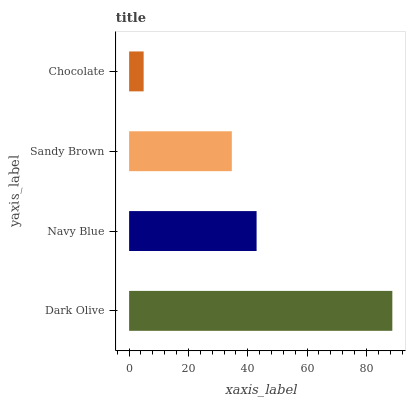Is Chocolate the minimum?
Answer yes or no. Yes. Is Dark Olive the maximum?
Answer yes or no. Yes. Is Navy Blue the minimum?
Answer yes or no. No. Is Navy Blue the maximum?
Answer yes or no. No. Is Dark Olive greater than Navy Blue?
Answer yes or no. Yes. Is Navy Blue less than Dark Olive?
Answer yes or no. Yes. Is Navy Blue greater than Dark Olive?
Answer yes or no. No. Is Dark Olive less than Navy Blue?
Answer yes or no. No. Is Navy Blue the high median?
Answer yes or no. Yes. Is Sandy Brown the low median?
Answer yes or no. Yes. Is Chocolate the high median?
Answer yes or no. No. Is Dark Olive the low median?
Answer yes or no. No. 